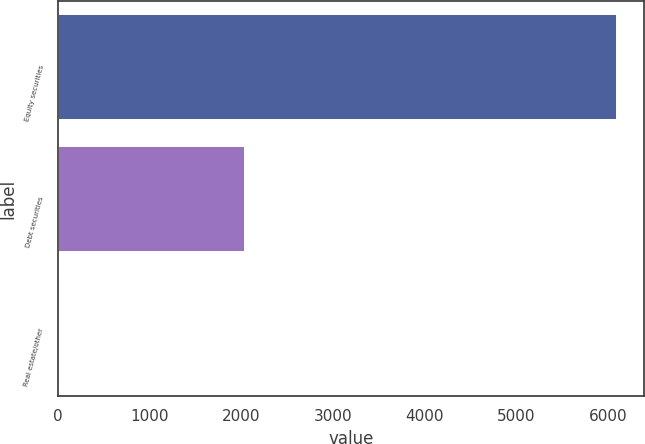Convert chart to OTSL. <chart><loc_0><loc_0><loc_500><loc_500><bar_chart><fcel>Equity securities<fcel>Debt securities<fcel>Real estate/other<nl><fcel>6080<fcel>2030<fcel>10<nl></chart> 